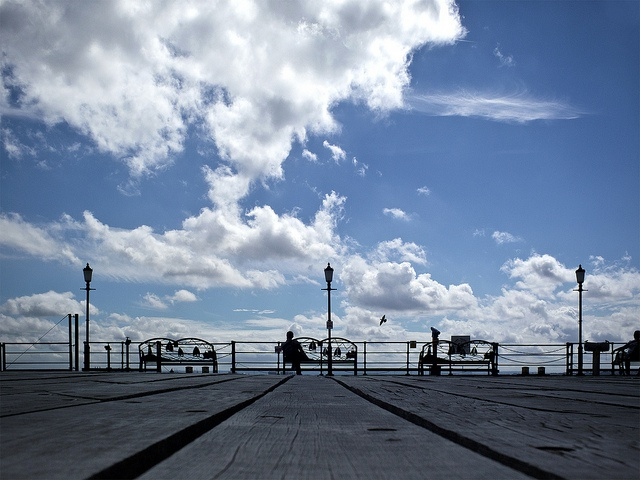Describe the objects in this image and their specific colors. I can see bench in lightgray, black, darkgray, and gray tones, bench in lightgray, black, gray, and darkgray tones, bench in lightgray, black, darkgray, and gray tones, people in lightgray, black, gray, and darkgray tones, and people in lightgray, black, darkgray, and gray tones in this image. 